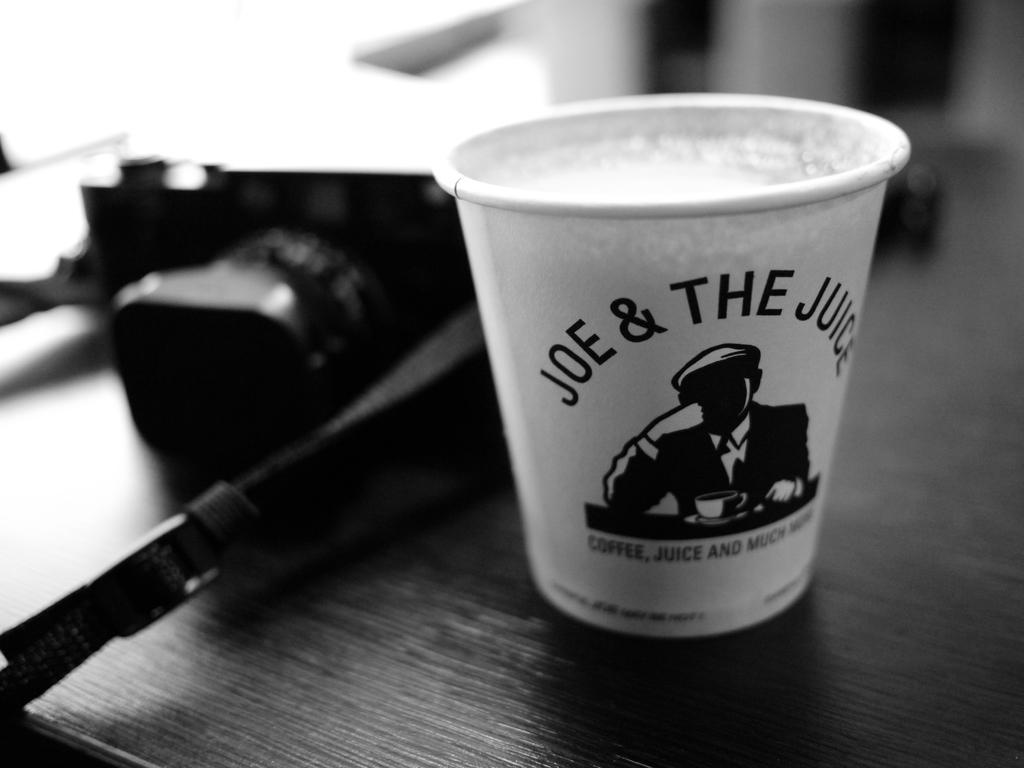<image>
Relay a brief, clear account of the picture shown. a cup on a desk that says Joe & The Juice 